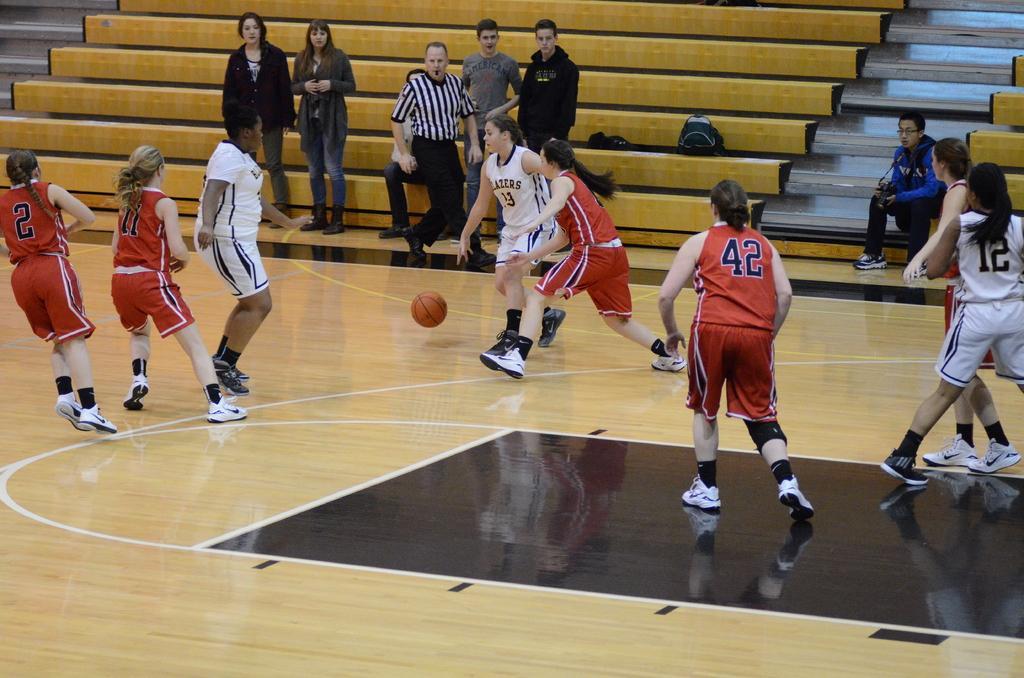Describe this image in one or two sentences. In the picture I can see these people wearing white color dresses and these people wearing red color dresses are playing in the court and here we can see the ball in the air. In the background, we can see a few more people standing there and this person on the right side is sitting on the steps. 